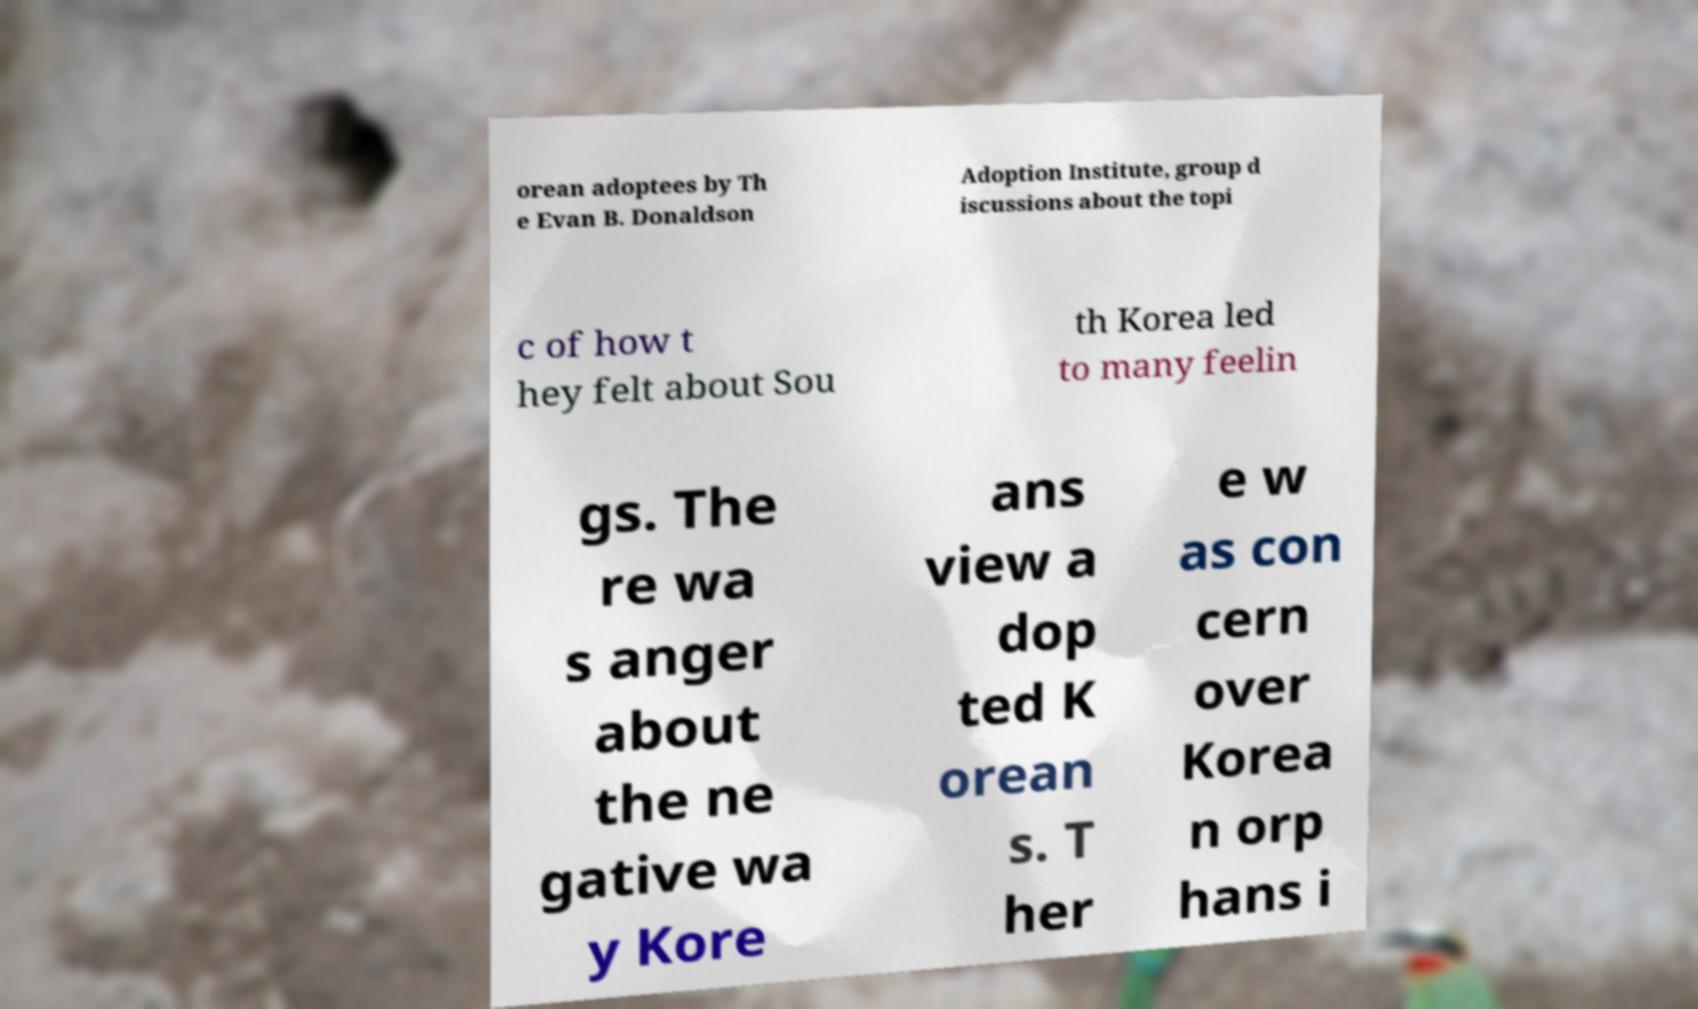Can you read and provide the text displayed in the image?This photo seems to have some interesting text. Can you extract and type it out for me? orean adoptees by Th e Evan B. Donaldson Adoption Institute, group d iscussions about the topi c of how t hey felt about Sou th Korea led to many feelin gs. The re wa s anger about the ne gative wa y Kore ans view a dop ted K orean s. T her e w as con cern over Korea n orp hans i 